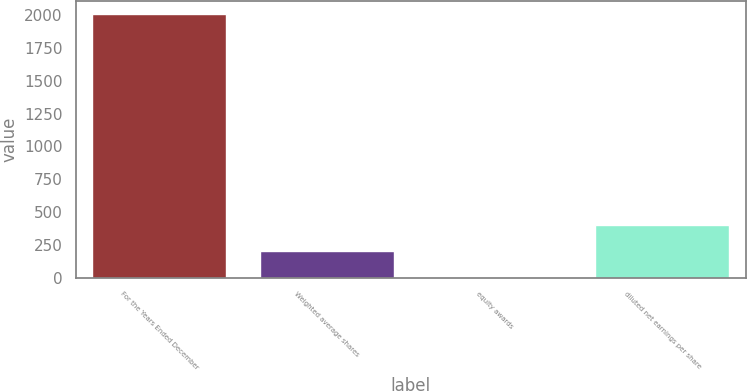Convert chart. <chart><loc_0><loc_0><loc_500><loc_500><bar_chart><fcel>For the Years Ended December<fcel>Weighted average shares<fcel>equity awards<fcel>diluted net earnings per share<nl><fcel>2011<fcel>202.09<fcel>1.1<fcel>403.08<nl></chart> 